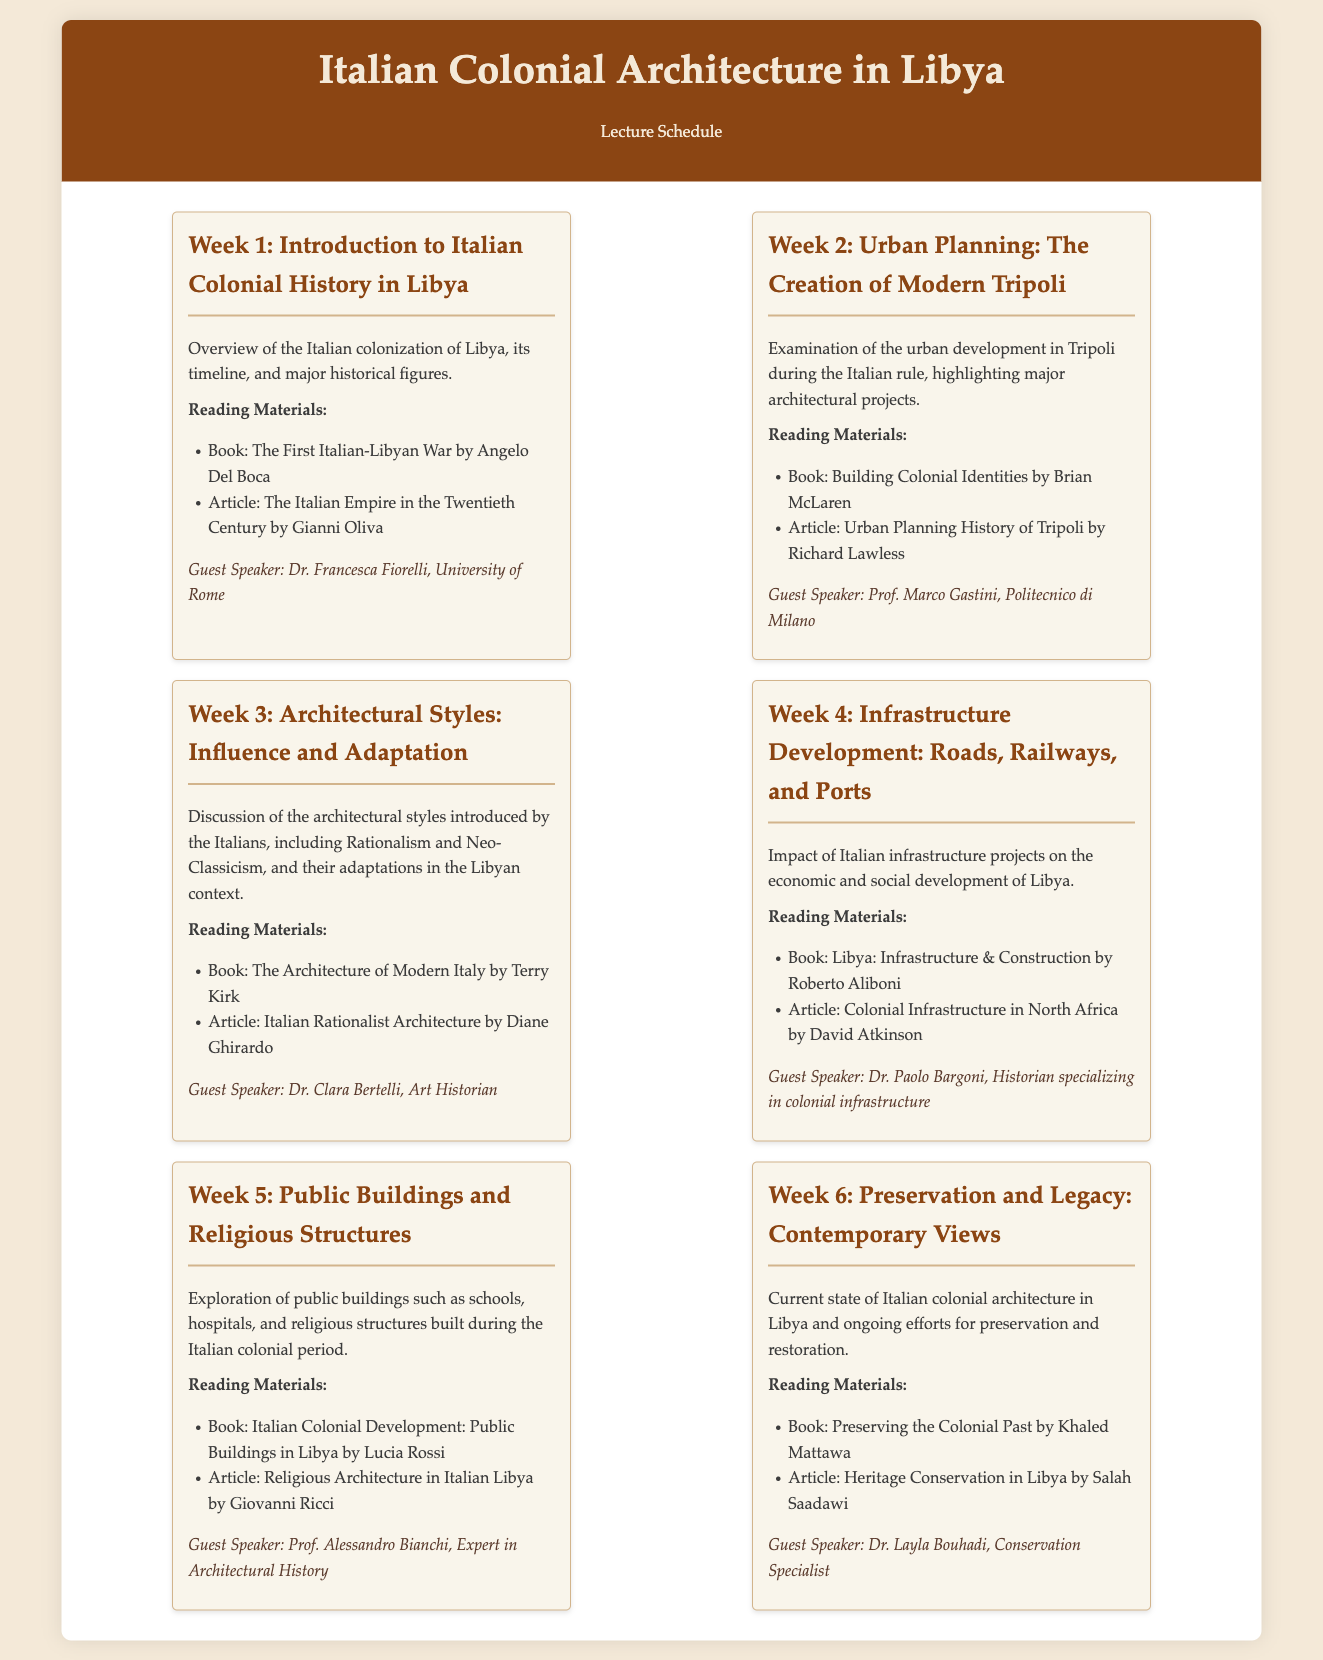What is the title of the first week's lecture? The title of the first week's lecture is found in the header of the first week section.
Answer: Introduction to Italian Colonial History in Libya Who is the guest speaker for Week 3? The guest speaker for Week 3 is listed in the respective week section under the guest speaker details.
Answer: Dr. Clara Bertelli How many weeks are covered in the lecture schedule? The total number of weeks can be counted from the number of distinct week sections in the document.
Answer: 6 What is the reading material for Week 2? The reading materials for Week 2 can be found listed under the second week section.
Answer: Building Colonial Identities by Brian McLaren What architectural styles are discussed in Week 3? The architectural styles are mentioned in the description of the Week 3 section.
Answer: Rationalism and Neo-Classicism Which book is recommended for reading in Week 5? The recommended book is specified in the reading materials of Week 5.
Answer: Italian Colonial Development: Public Buildings in Libya by Lucia Rossi 